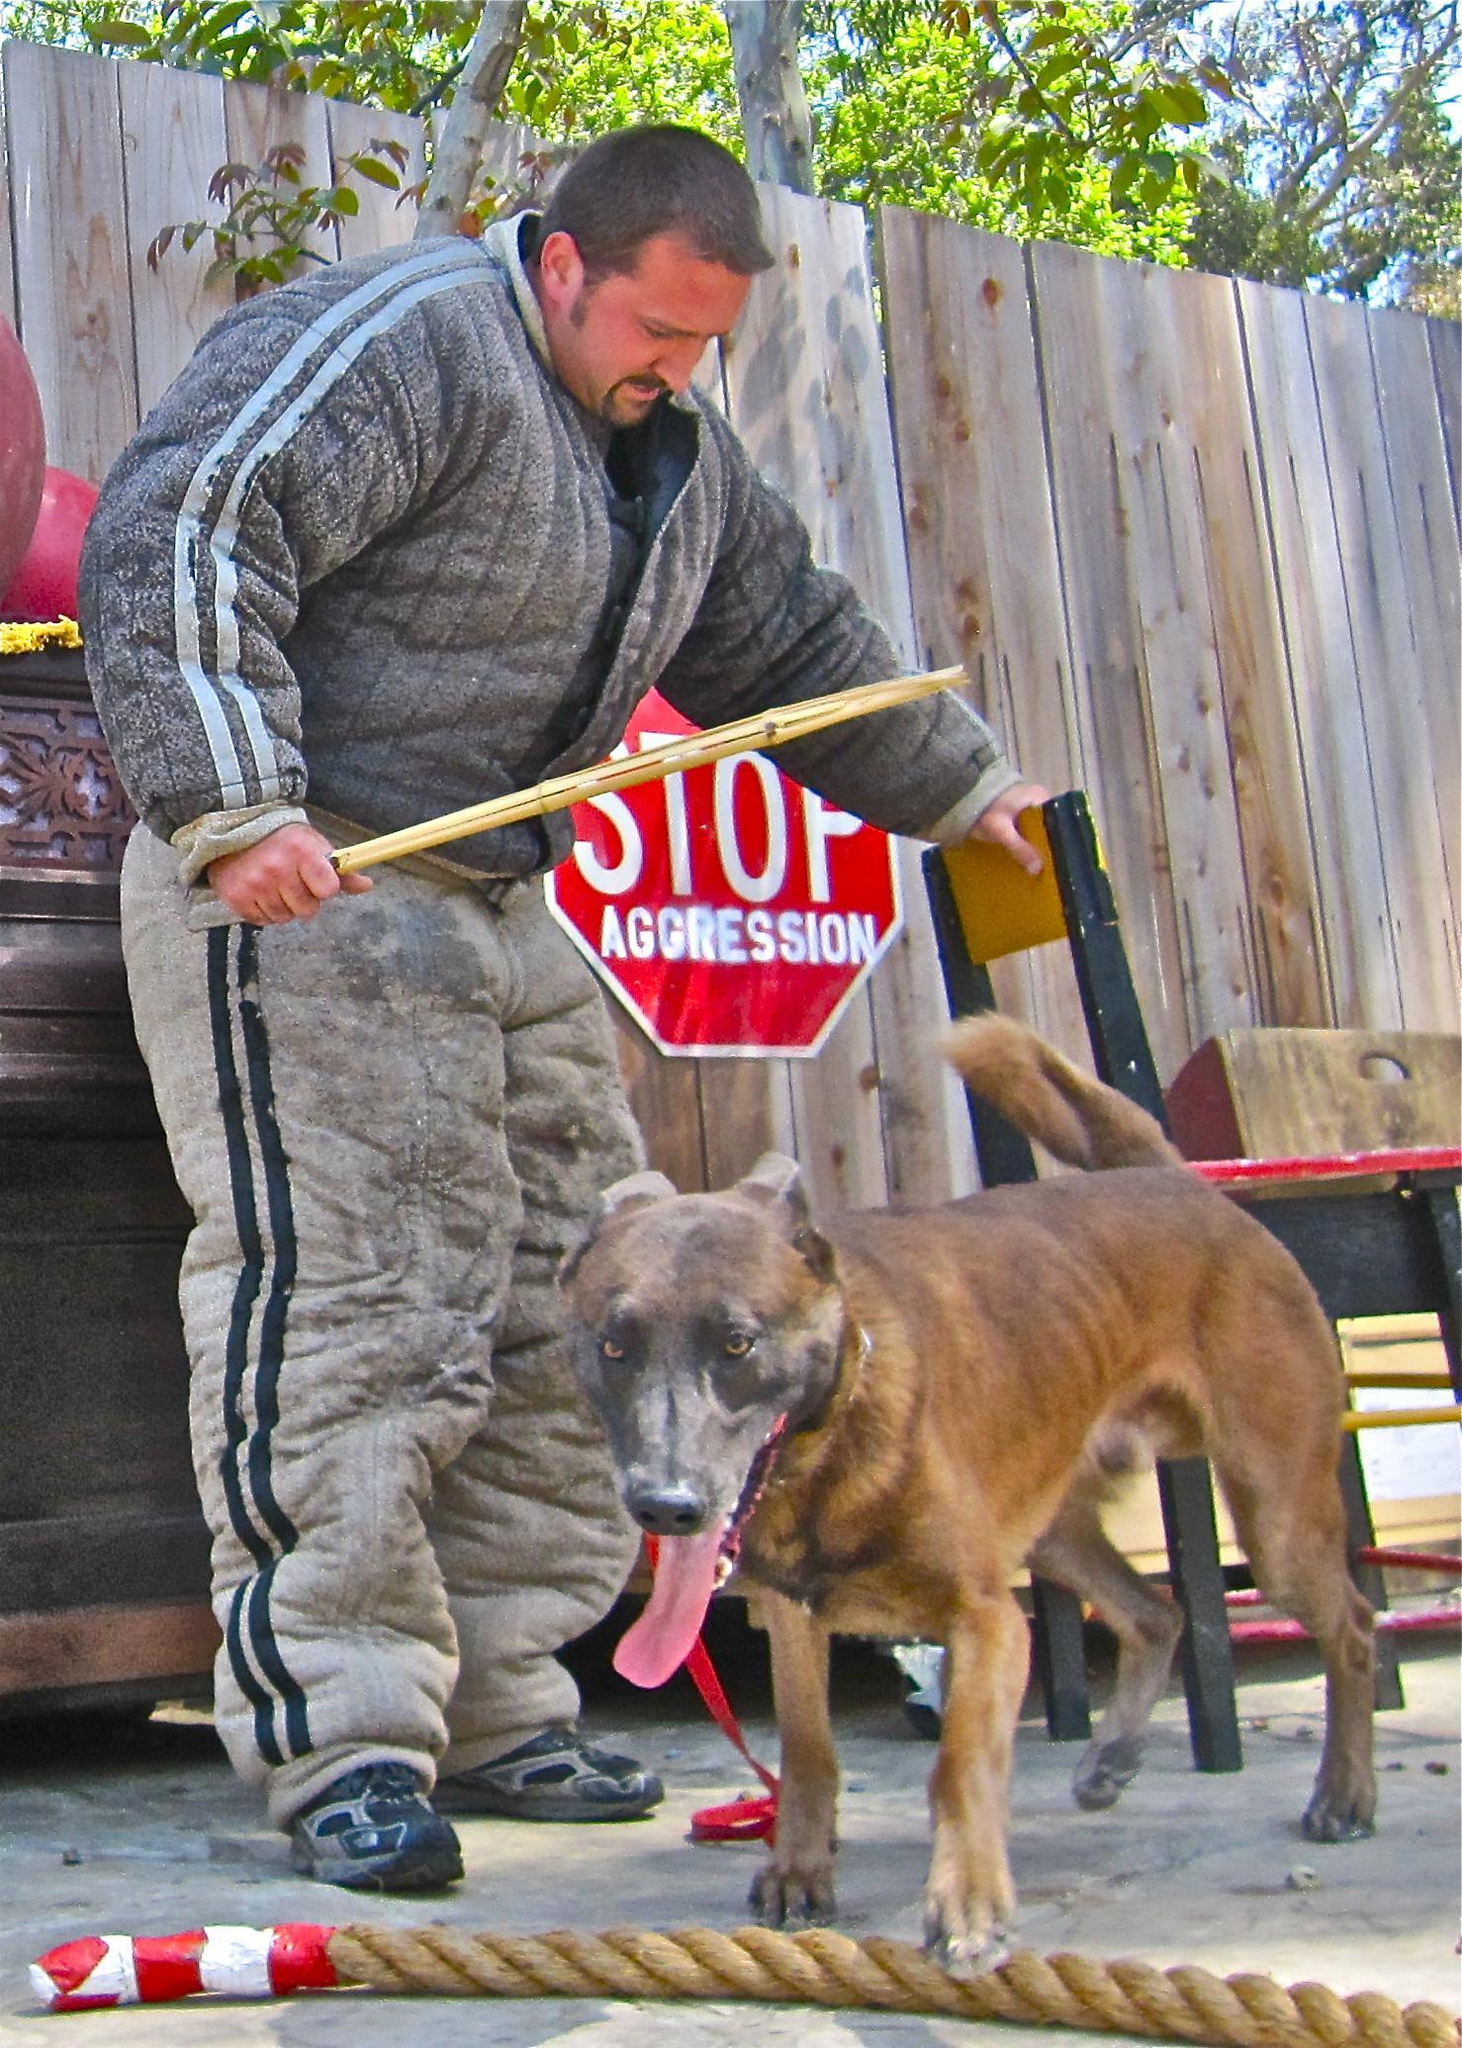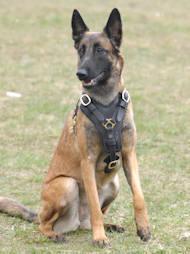The first image is the image on the left, the second image is the image on the right. For the images shown, is this caption "There is a single human in the pair of images." true? Answer yes or no. Yes. The first image is the image on the left, the second image is the image on the right. For the images displayed, is the sentence "One image shows a german shepherd in a harness vest sitting upright, and the othe image shows a man in padded pants holding a stick near a dog." factually correct? Answer yes or no. Yes. 